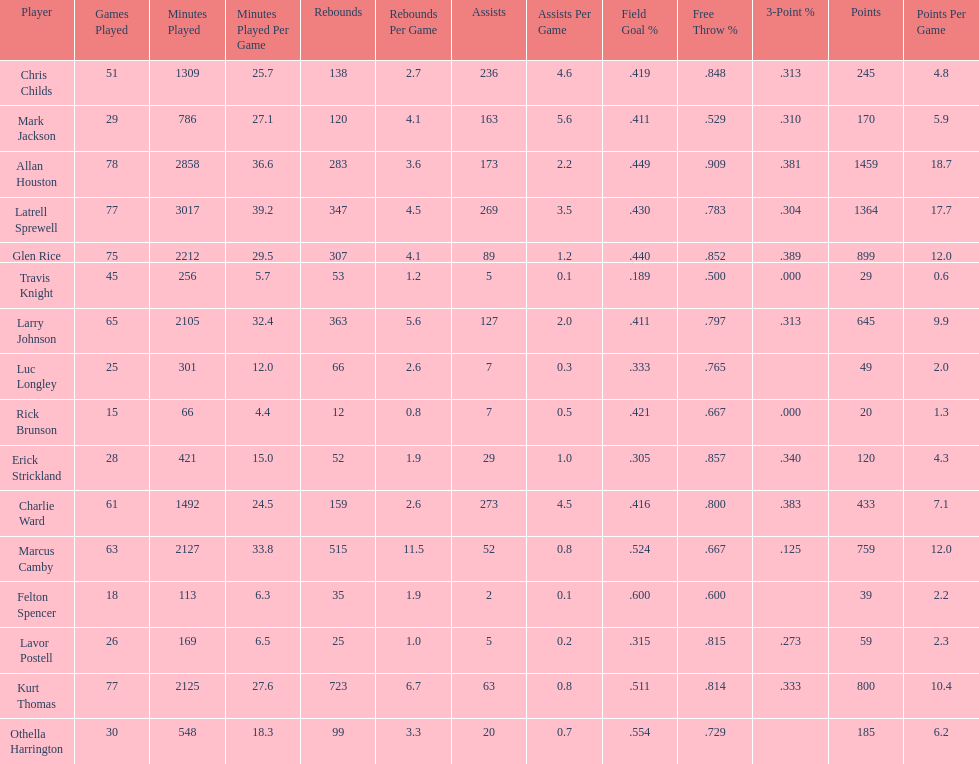How many games did larry johnson play? 65. 